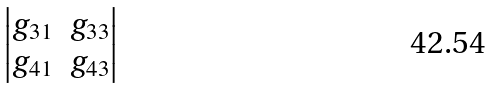Convert formula to latex. <formula><loc_0><loc_0><loc_500><loc_500>\begin{vmatrix} g _ { 3 1 } & g _ { 3 3 } \\ g _ { 4 1 } & g _ { 4 3 } \end{vmatrix}</formula> 